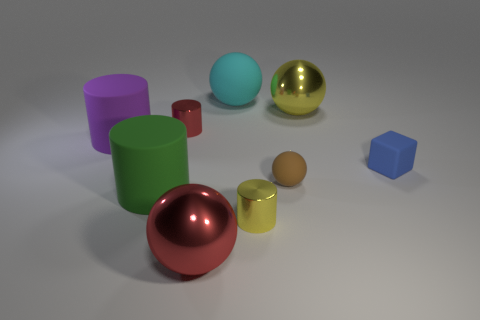Is the cyan object made of the same material as the small cylinder that is in front of the small blue cube?
Provide a short and direct response. No. How many blue objects are small metal things or large balls?
Offer a terse response. 0. Are there any matte things of the same size as the cube?
Offer a very short reply. Yes. There is a big sphere on the right side of the large matte object to the right of the big ball that is in front of the green rubber thing; what is it made of?
Offer a very short reply. Metal. Are there the same number of green cylinders that are right of the small cube and large rubber spheres?
Make the answer very short. No. Is the material of the red thing that is in front of the tiny red metal cylinder the same as the large cylinder behind the big green rubber cylinder?
Your response must be concise. No. What number of things are green objects or cylinders that are behind the small yellow thing?
Make the answer very short. 3. Is there a small brown object of the same shape as the green thing?
Your answer should be very brief. No. What is the size of the thing in front of the small metal cylinder that is in front of the metal cylinder that is on the left side of the large cyan rubber ball?
Your response must be concise. Large. Are there the same number of large balls on the right side of the large yellow ball and cyan matte objects that are on the right side of the large red shiny sphere?
Provide a short and direct response. No. 